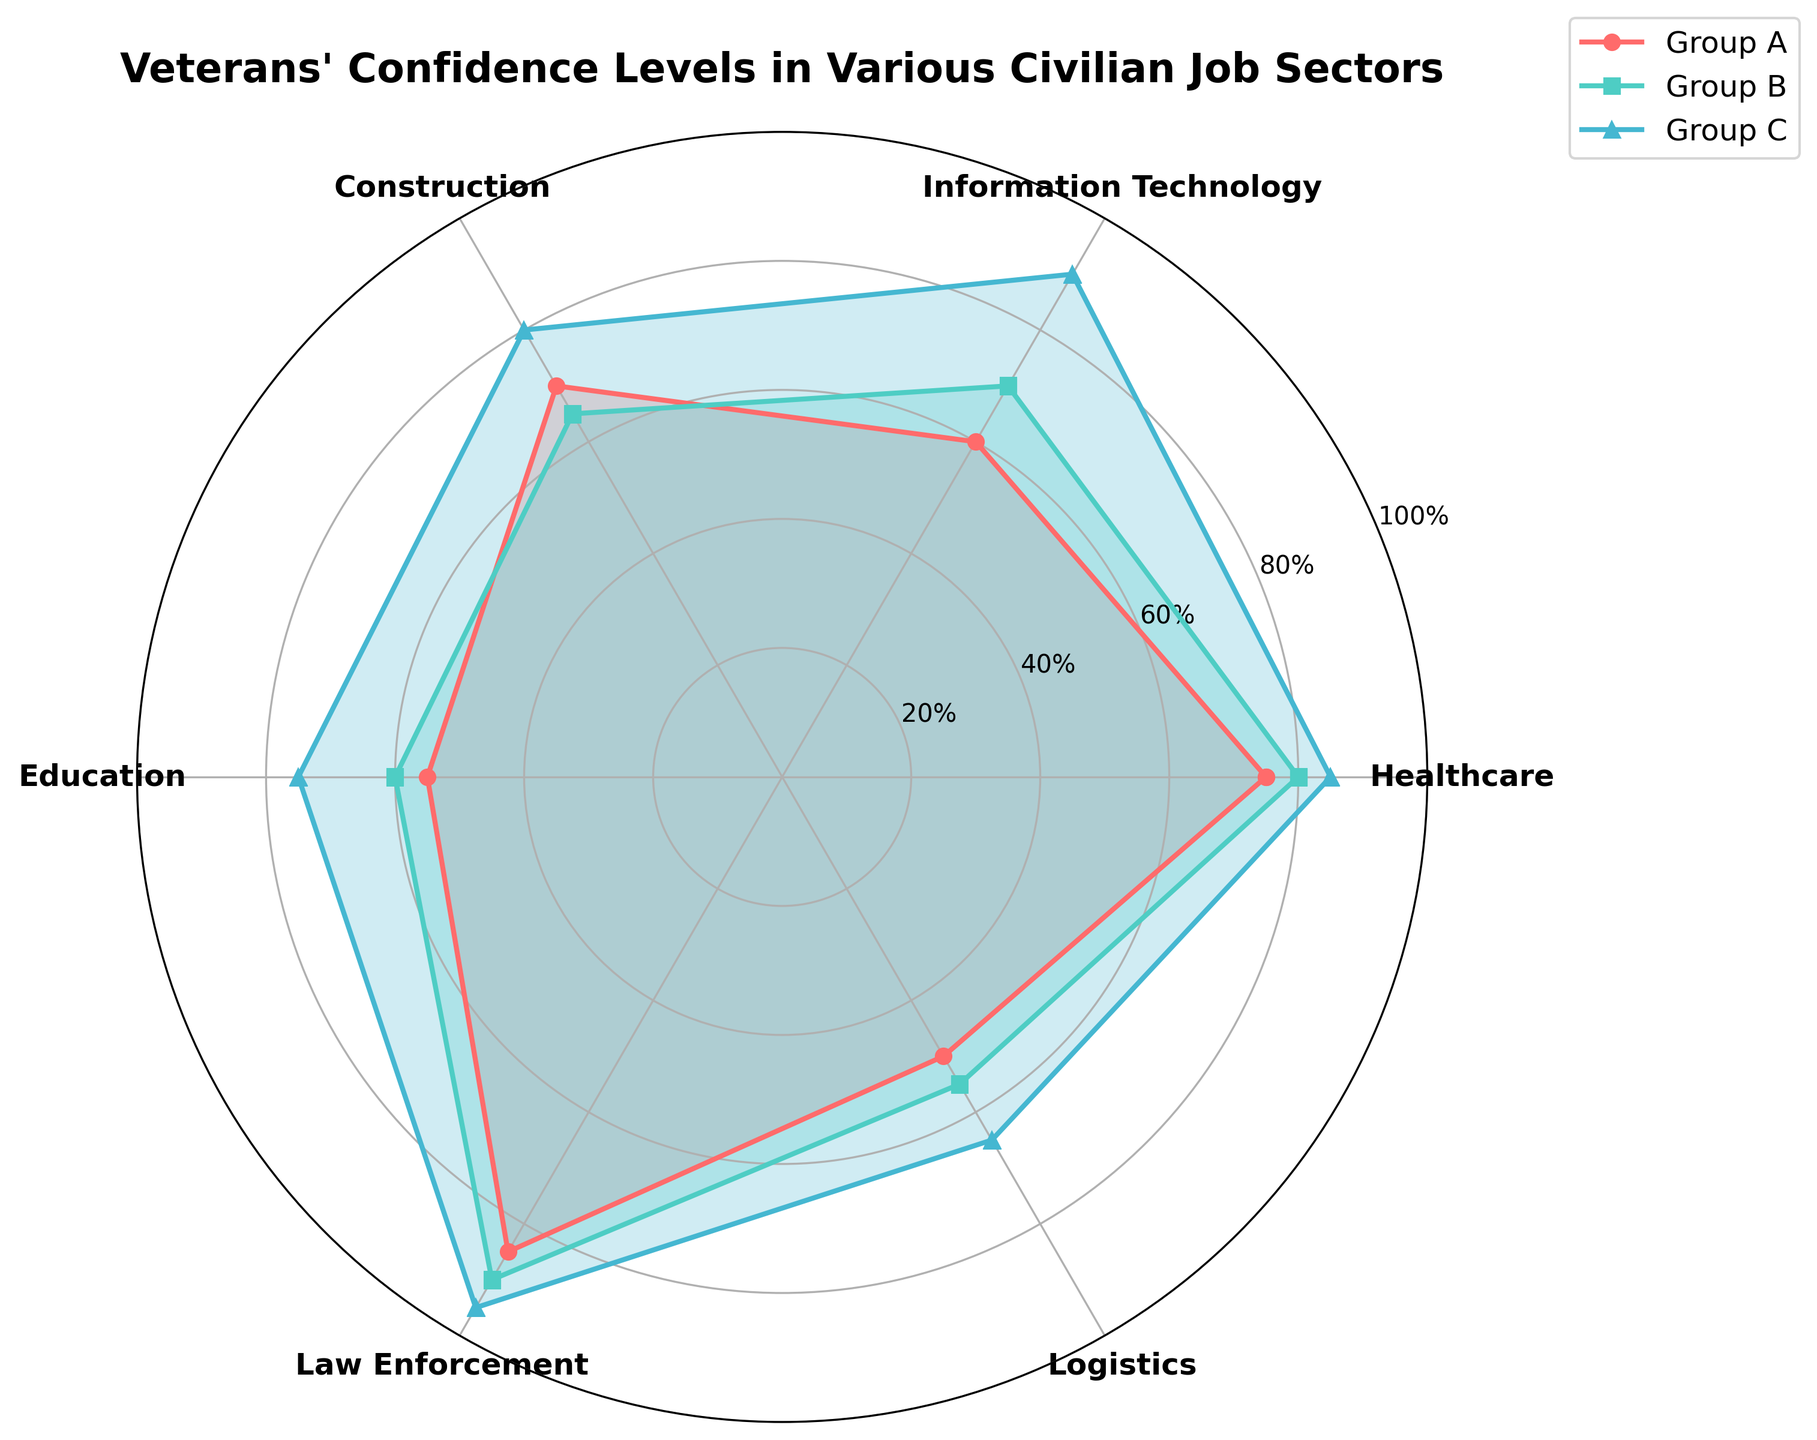What is the title of the radar chart? The title is shown at the top of the radar chart.
Answer: Veterans' Confidence Levels in Various Civilian Job Sectors Which group has the highest average confidence level across all sectors? To find the average confidence level for each group, sum their confidence levels across all sectors and divide by the number of sectors. Group A: (75+60+70+55+85+50)/6 = 65.83, Group B: (80+70+65+60+90+55)/6 = 70, Group C: (85+90+80+75+95+65)/6 = 81.67
Answer: Group C Which sector shows the most consistent confidence levels across all groups? Consistency can be seen by the smallest variance between the groups' confidence levels in each sector. For instance, comparing each group's confidence levels, Law Enforcement (85, 90, 95) has a variance of 25, which is the smallest among all sectors.
Answer: Law Enforcement How does Group B's confidence in Education compare to Group A's confidence in Information Technology? Group B's confidence in Education is 60%, and Group A's confidence in Information Technology is 60%.
Answer: They are equal What is the difference between the highest and lowest confidence levels in Healthcare across all groups? In Healthcare, the highest confidence level is 85% (Group C), and the lowest is 75% (Group A). The difference is 85% - 75% = 10%.
Answer: 10% Which group has the lowest confidence level in Logistics? By checking the values, Group A has the lowest confidence level in Logistics at 50%.
Answer: Group A What is the median value of confidence levels in Group C across all sectors? First, the data in Group C across all sectors: 85, 90, 80, 75, 95, 65. When arranged in ascending order: 65, 75, 80, 85, 90, 95, the median value (average of the 3rd and 4th values) is (80 + 85)/2 = 82.5.
Answer: 82.5 Which sector has the largest confidence gap between Group A and Group B? Calculate the difference for each sector: Healthcare (5), IT (10), Construction (5), Education (5), Law Enforcement (5), Logistics (5). The largest gap is in Information Technology with a difference of 10.
Answer: Information Technology In which sector does Group C show the highest confidence? The highest value in Group C is checked across all sectors. The highest confidence level of 95% is in Law Enforcement.
Answer: Law Enforcement 